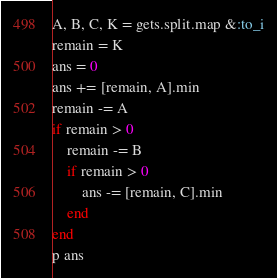<code> <loc_0><loc_0><loc_500><loc_500><_Ruby_>A, B, C, K = gets.split.map &:to_i
remain = K
ans = 0
ans += [remain, A].min
remain -= A
if remain > 0
    remain -= B
    if remain > 0
        ans -= [remain, C].min
    end
end
p ans</code> 